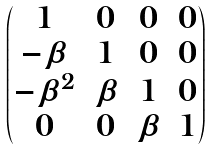Convert formula to latex. <formula><loc_0><loc_0><loc_500><loc_500>\begin{pmatrix} 1 & 0 & 0 & 0 \\ - \beta & 1 & 0 & 0 \\ - \beta ^ { 2 } & \beta & 1 & 0 \\ 0 & 0 & \beta & 1 \end{pmatrix}</formula> 